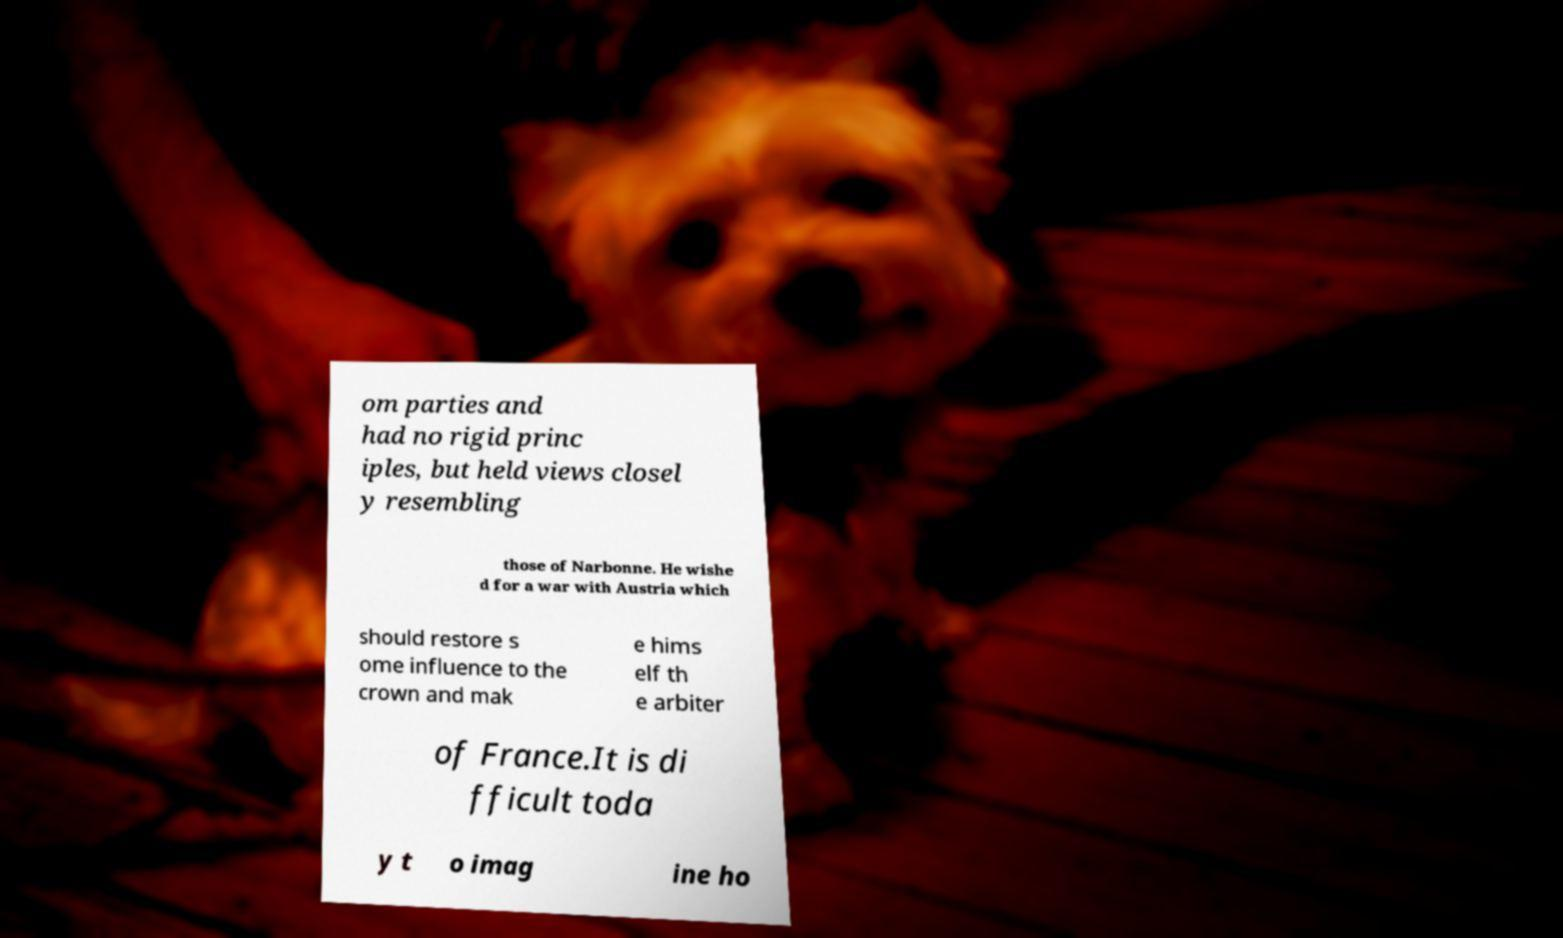Can you accurately transcribe the text from the provided image for me? om parties and had no rigid princ iples, but held views closel y resembling those of Narbonne. He wishe d for a war with Austria which should restore s ome influence to the crown and mak e hims elf th e arbiter of France.It is di fficult toda y t o imag ine ho 